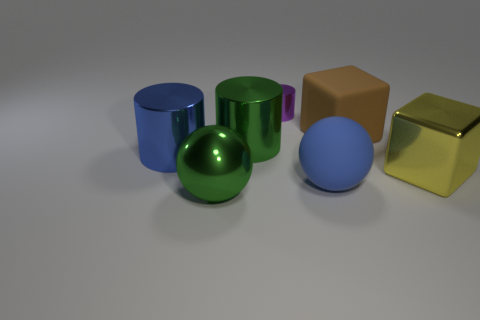There is a shiny thing that is the same color as the large shiny ball; what size is it?
Give a very brief answer. Large. Are there fewer large shiny cubes that are behind the blue shiny cylinder than big blue cylinders?
Provide a short and direct response. Yes. Are there any large cyan matte things of the same shape as the purple shiny thing?
Your answer should be very brief. No. What is the shape of the brown thing that is the same size as the blue matte ball?
Provide a succinct answer. Cube. What number of objects are either big yellow blocks or small cylinders?
Your answer should be very brief. 2. Are any blocks visible?
Offer a terse response. Yes. Are there fewer large yellow blocks than tiny cyan matte spheres?
Offer a terse response. No. Is there a green metal cylinder of the same size as the purple shiny cylinder?
Offer a very short reply. No. Do the small metallic object and the rubber thing that is to the left of the big brown block have the same shape?
Your response must be concise. No. How many spheres are green things or metal objects?
Your answer should be compact. 1. 